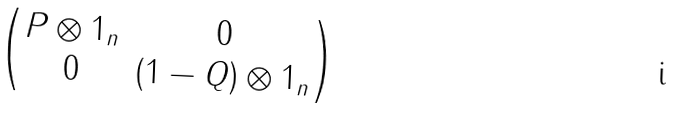<formula> <loc_0><loc_0><loc_500><loc_500>\begin{pmatrix} P \otimes 1 _ { n } & 0 \\ 0 & ( 1 - Q ) \otimes 1 _ { n } \end{pmatrix}</formula> 